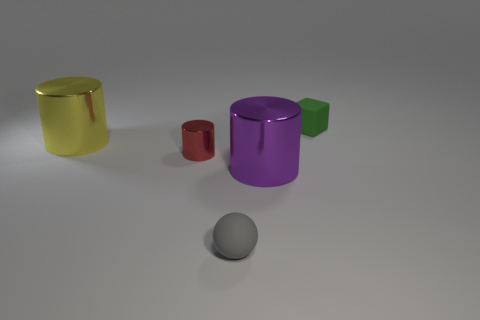Subtract all big cylinders. How many cylinders are left? 1 Add 1 big green rubber cubes. How many objects exist? 6 Subtract all purple cylinders. How many cylinders are left? 2 Subtract all blocks. How many objects are left? 4 Subtract 1 cylinders. How many cylinders are left? 2 Subtract all small cyan blocks. Subtract all small cylinders. How many objects are left? 4 Add 5 purple cylinders. How many purple cylinders are left? 6 Add 4 small things. How many small things exist? 7 Subtract 0 red blocks. How many objects are left? 5 Subtract all brown cylinders. Subtract all yellow balls. How many cylinders are left? 3 